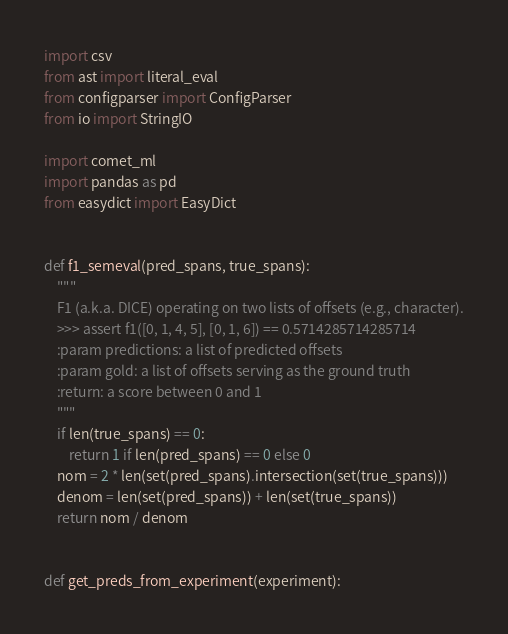Convert code to text. <code><loc_0><loc_0><loc_500><loc_500><_Python_>import csv
from ast import literal_eval
from configparser import ConfigParser
from io import StringIO

import comet_ml
import pandas as pd
from easydict import EasyDict


def f1_semeval(pred_spans, true_spans):
    """
    F1 (a.k.a. DICE) operating on two lists of offsets (e.g., character).
    >>> assert f1([0, 1, 4, 5], [0, 1, 6]) == 0.5714285714285714
    :param predictions: a list of predicted offsets
    :param gold: a list of offsets serving as the ground truth
    :return: a score between 0 and 1
    """
    if len(true_spans) == 0:
        return 1 if len(pred_spans) == 0 else 0
    nom = 2 * len(set(pred_spans).intersection(set(true_spans)))
    denom = len(set(pred_spans)) + len(set(true_spans))
    return nom / denom


def get_preds_from_experiment(experiment):</code> 